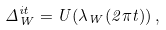Convert formula to latex. <formula><loc_0><loc_0><loc_500><loc_500>\Delta _ { W } ^ { i t } = U ( \lambda _ { W } ( 2 \pi t ) ) \, ,</formula> 